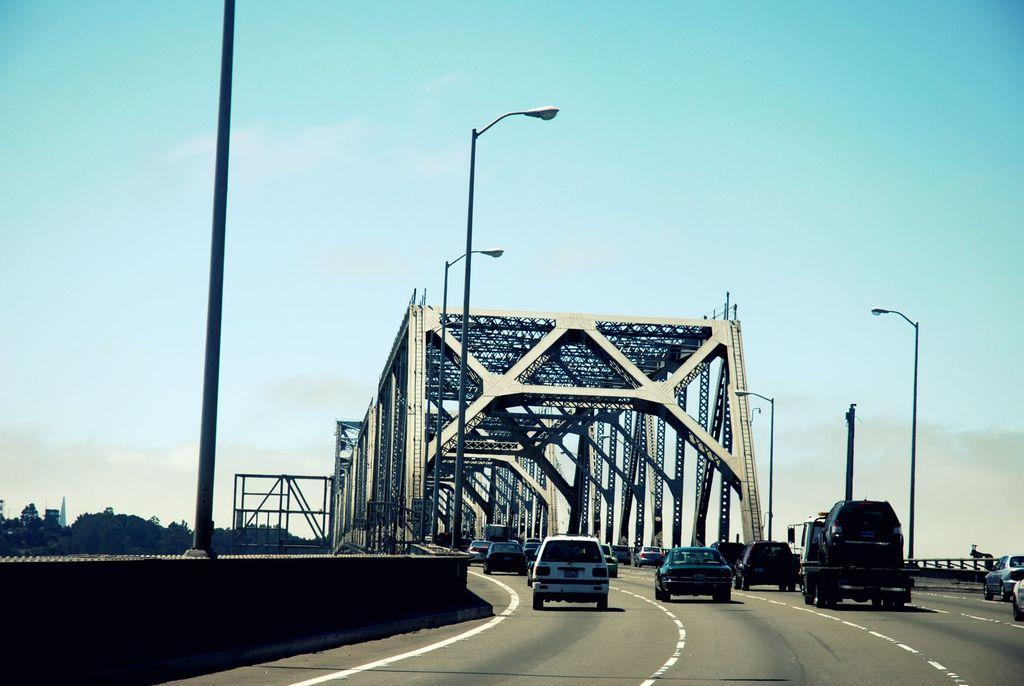What types of objects can be seen in the image? There are vehicles, poles, metallic arches, and objects on the left side of the image. What is the ground like in the image? The ground is visible in the image. What is the background of the image? There is a wall and the sky is visible in the image, with clouds present. Can you describe the metallic arches in the image? The metallic arches are structures that can be seen in the image. What type of suit is the carpenter wearing in the image? There is no carpenter or suit present in the image. What material is the brass used for in the image? There is no brass present in the image. 